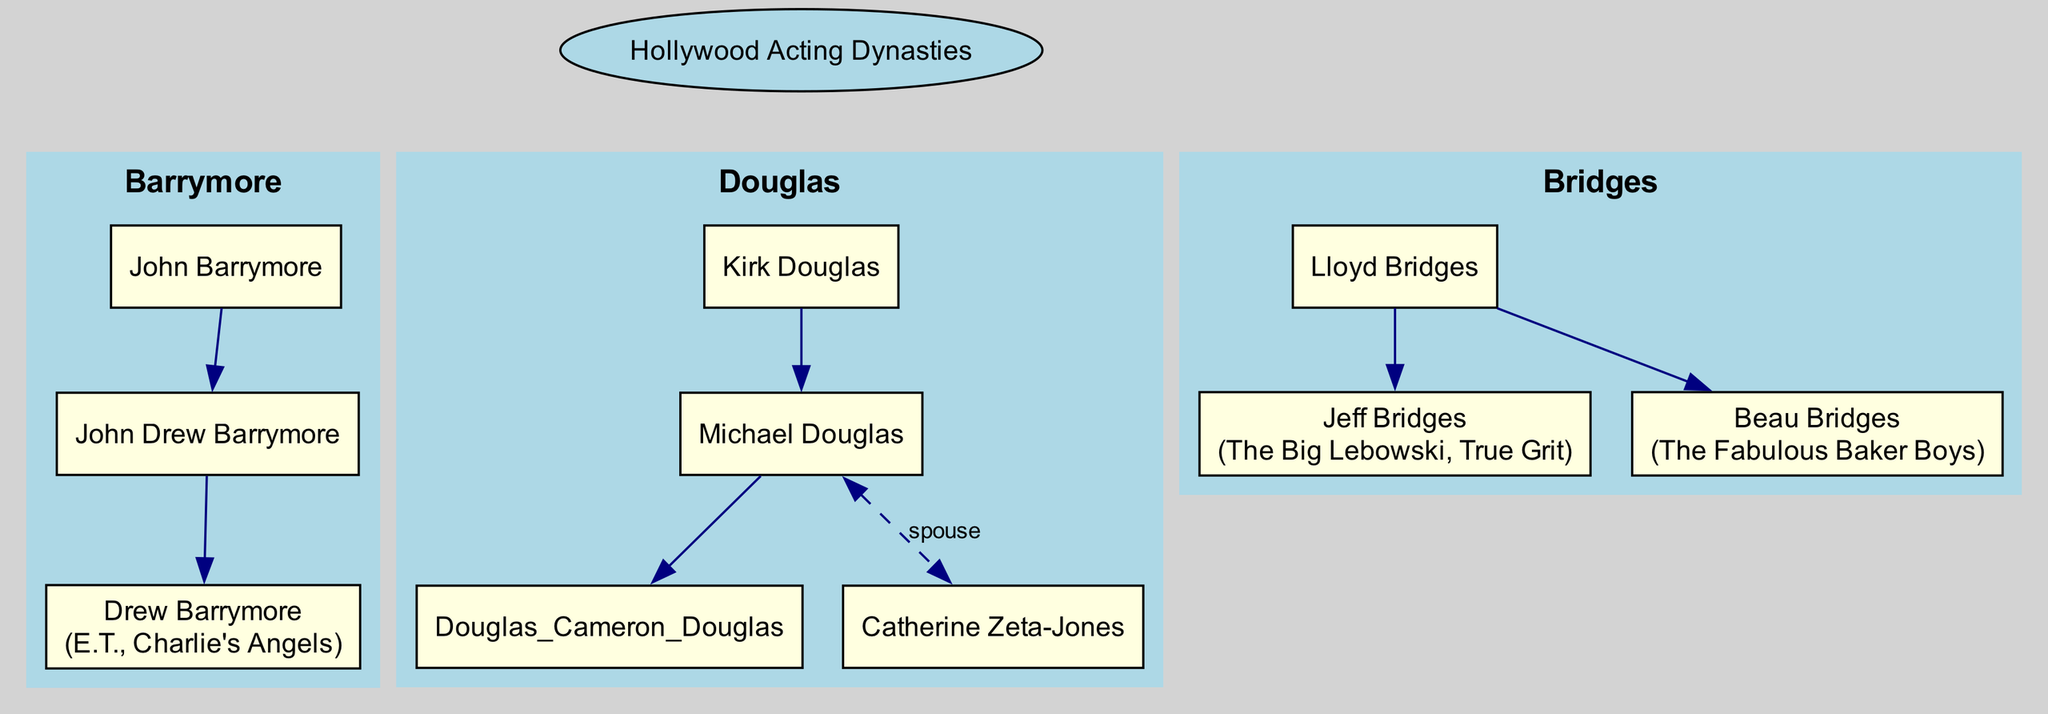How many acting dynasties are shown in the diagram? The diagram presents three distinct acting dynasties, as represented in the families array: Barrymore, Douglas, and Bridges.
Answer: 3 Who are the children of John Barrymore? According to the diagram, John Barrymore has one child listed, which is John Drew Barrymore. This is directly shown under the Barrymore family section.
Answer: John Drew Barrymore What notable role is associated with Jeff Bridges? The diagram indicates that Jeff Bridges is known for notable roles in "The Big Lebowski" and "True Grit," which are specifically mentioned in his member details.
Answer: The Big Lebowski How many children does Michael Douglas have? The diagram shows that Michael Douglas has one child, Cameron Douglas, as indicated under his member details, confirming the parent-child relationship.
Answer: 1 Which family does Drew Barrymore belong to? Drew Barrymore is a member of the Barrymore family, as provided in the family tree; her lineage connects back through John Barrymore and John Drew Barrymore.
Answer: Barrymore Who is the spouse of Michael Douglas? The diagram specifies that Michael Douglas is married to Catherine Zeta-Jones, indicated by the dashed edge that connects them in the family tree format.
Answer: Catherine Zeta-Jones What is the relationship between Kirk Douglas and Michael Douglas? The diagram reveals a direct parent-child relationship, where Kirk Douglas is the father of Michael Douglas, shown by the edge connecting their nodes.
Answer: Father Which family includes both Jeff Bridges and Beau Bridges? The Bridges family encompasses both Jeff Bridges and Beau Bridges, as depicted in the member section of the Bridges family's details.
Answer: Bridges What role did Drew Barrymore play in "E.T."? The diagram mentions Drew Barrymore as a notable actor in "E.T.," highlighting her contributions to well-known films in her acting career.
Answer: E.T 